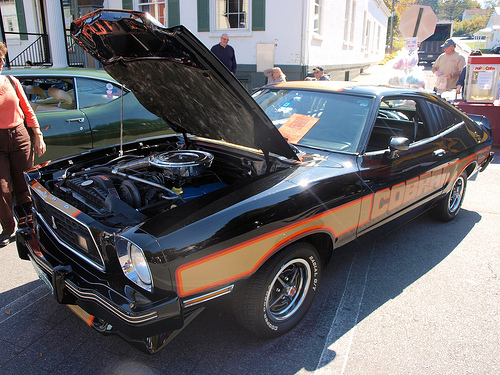<image>
Is the man on the car? No. The man is not positioned on the car. They may be near each other, but the man is not supported by or resting on top of the car. 